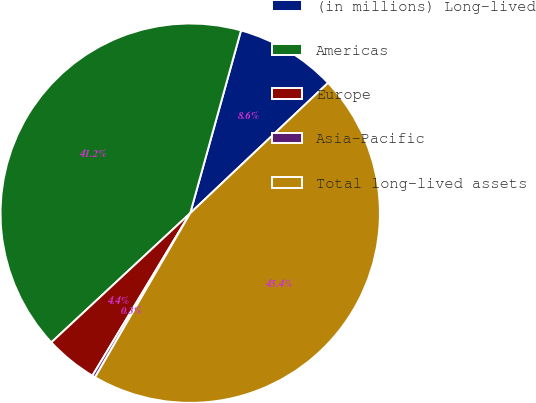Convert chart to OTSL. <chart><loc_0><loc_0><loc_500><loc_500><pie_chart><fcel>(in millions) Long-lived<fcel>Americas<fcel>Europe<fcel>Asia-Pacific<fcel>Total long-lived assets<nl><fcel>8.63%<fcel>41.24%<fcel>4.45%<fcel>0.26%<fcel>45.42%<nl></chart> 